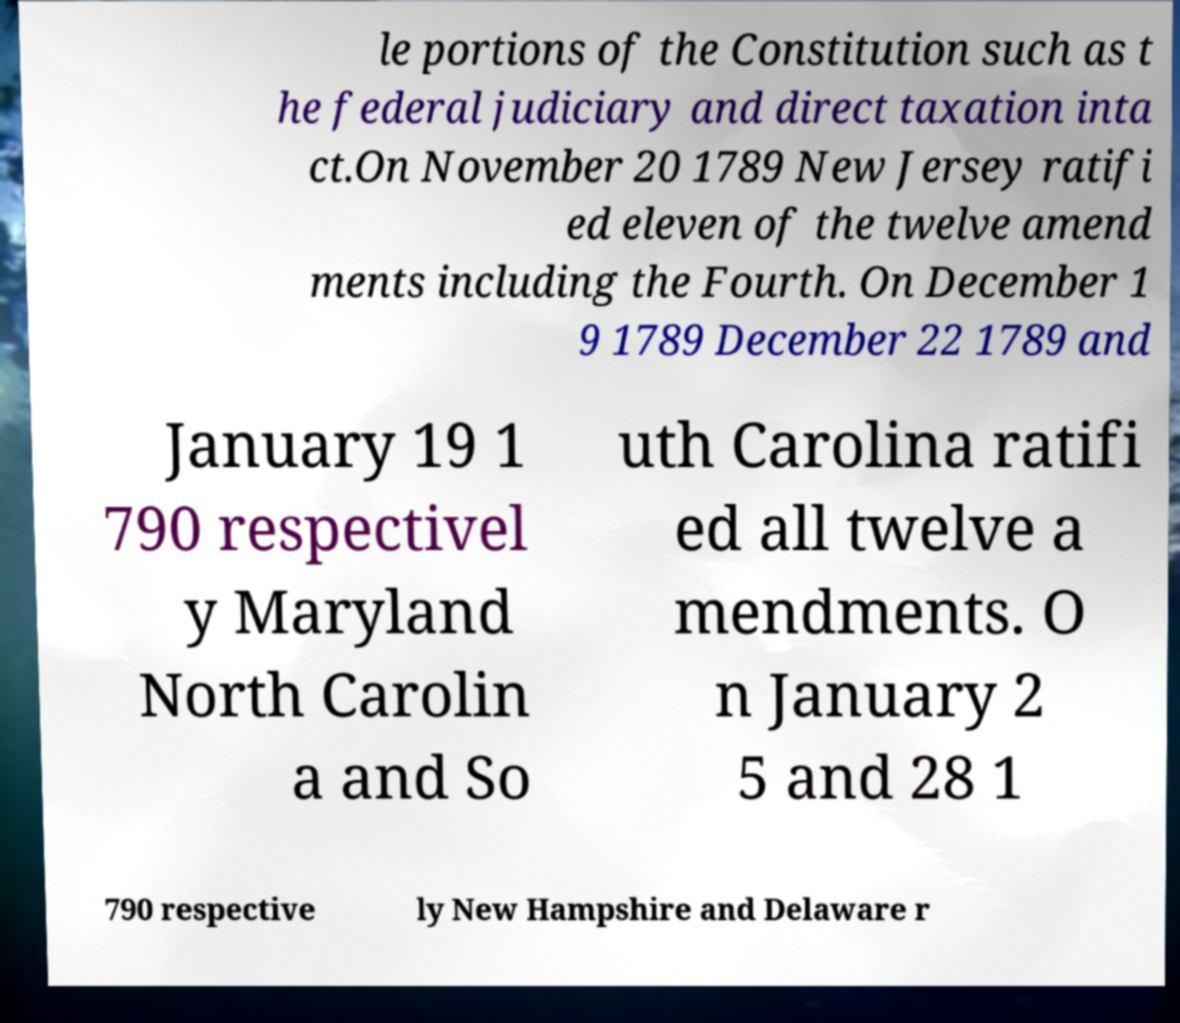Can you read and provide the text displayed in the image?This photo seems to have some interesting text. Can you extract and type it out for me? le portions of the Constitution such as t he federal judiciary and direct taxation inta ct.On November 20 1789 New Jersey ratifi ed eleven of the twelve amend ments including the Fourth. On December 1 9 1789 December 22 1789 and January 19 1 790 respectivel y Maryland North Carolin a and So uth Carolina ratifi ed all twelve a mendments. O n January 2 5 and 28 1 790 respective ly New Hampshire and Delaware r 